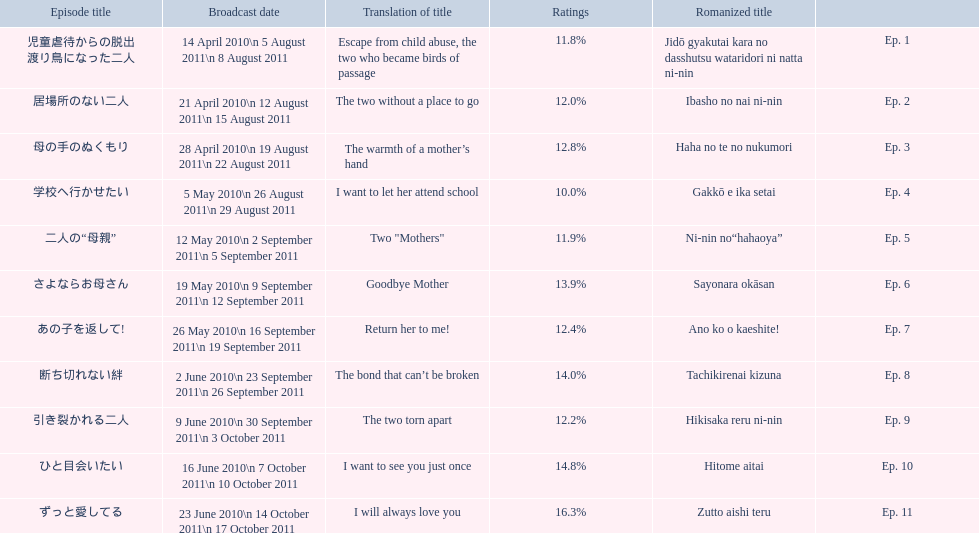What are all of the episode numbers? Ep. 1, Ep. 2, Ep. 3, Ep. 4, Ep. 5, Ep. 6, Ep. 7, Ep. 8, Ep. 9, Ep. 10, Ep. 11. And their titles? 児童虐待からの脱出 渡り鳥になった二人, 居場所のない二人, 母の手のぬくもり, 学校へ行かせたい, 二人の“母親”, さよならお母さん, あの子を返して!, 断ち切れない絆, 引き裂かれる二人, ひと目会いたい, ずっと愛してる. What about their translated names? Escape from child abuse, the two who became birds of passage, The two without a place to go, The warmth of a mother’s hand, I want to let her attend school, Two "Mothers", Goodbye Mother, Return her to me!, The bond that can’t be broken, The two torn apart, I want to see you just once, I will always love you. Which episode number's title translated to i want to let her attend school? Ep. 4. 